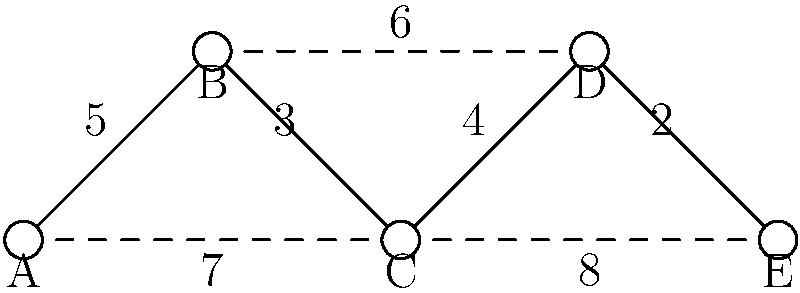Given the network diagram representing server connections, where solid lines indicate primary connections and dashed lines represent backup connections, what is the minimum total weight of connections required to ensure all servers are connected while minimizing costs? Assume that implementing backup connections incurs additional setup costs, potentially increasing financial burden. To solve this problem, we'll use the concept of a Minimum Spanning Tree (MST) while considering the financial implications of backup connections.

Step 1: Identify all possible connections and their weights:
- A-B: 5
- B-C: 3
- C-D: 4
- D-E: 2
- A-C: 7 (backup)
- B-D: 6 (backup)
- C-E: 8 (backup)

Step 2: Apply Kruskal's algorithm to find the MST:
1. Sort edges by weight: D-E (2), B-C (3), C-D (4), A-B (5)
2. Add edges to the MST:
   - Add D-E (2)
   - Add B-C (3)
   - Add C-D (4)
   - Add A-B (5)

Step 3: Verify connectivity:
The selected edges (A-B, B-C, C-D, D-E) connect all nodes without forming a cycle.

Step 4: Calculate total weight:
Total weight = 2 + 3 + 4 + 5 = 14

Step 5: Consider financial implications:
Using only primary connections (solid lines) minimizes setup costs by avoiding the implementation of backup connections, which aligns with the developer's concern about financial burdens.

Therefore, the minimum total weight of connections required to ensure all servers are connected while minimizing costs is 14.
Answer: 14 